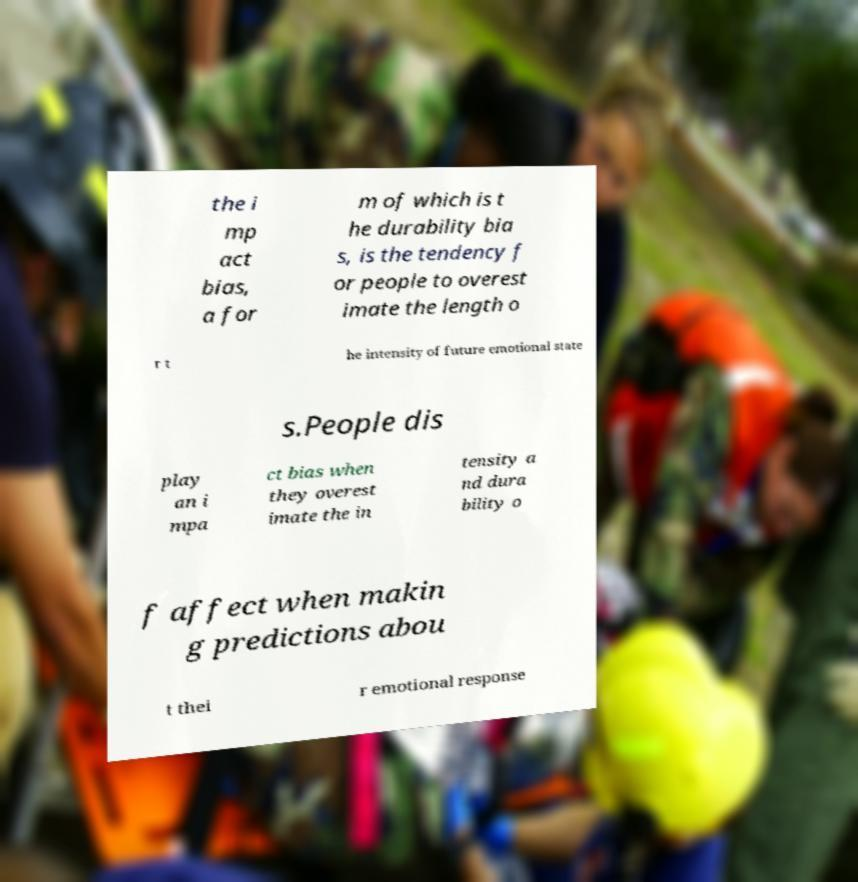Can you accurately transcribe the text from the provided image for me? the i mp act bias, a for m of which is t he durability bia s, is the tendency f or people to overest imate the length o r t he intensity of future emotional state s.People dis play an i mpa ct bias when they overest imate the in tensity a nd dura bility o f affect when makin g predictions abou t thei r emotional response 